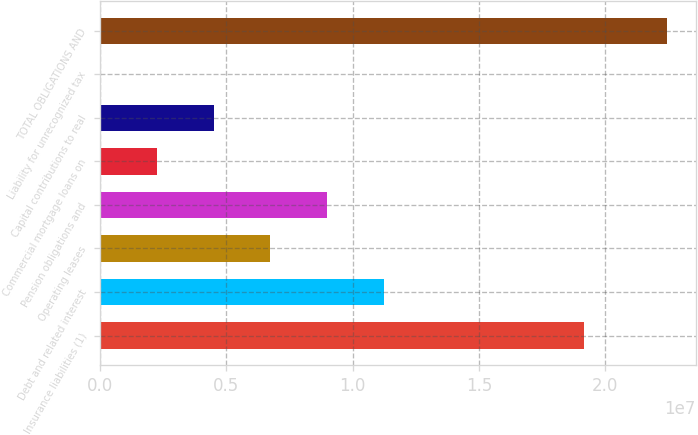Convert chart. <chart><loc_0><loc_0><loc_500><loc_500><bar_chart><fcel>Insurance liabilities (1)<fcel>Debt and related interest<fcel>Operating leases<fcel>Pension obligations and<fcel>Commercial mortgage loans on<fcel>Capital contributions to real<fcel>Liability for unrecognized tax<fcel>TOTAL OBLIGATIONS AND<nl><fcel>1.91499e+07<fcel>1.12396e+07<fcel>6.74879e+06<fcel>8.99421e+06<fcel>2.25794e+06<fcel>4.50336e+06<fcel>12510<fcel>2.24668e+07<nl></chart> 